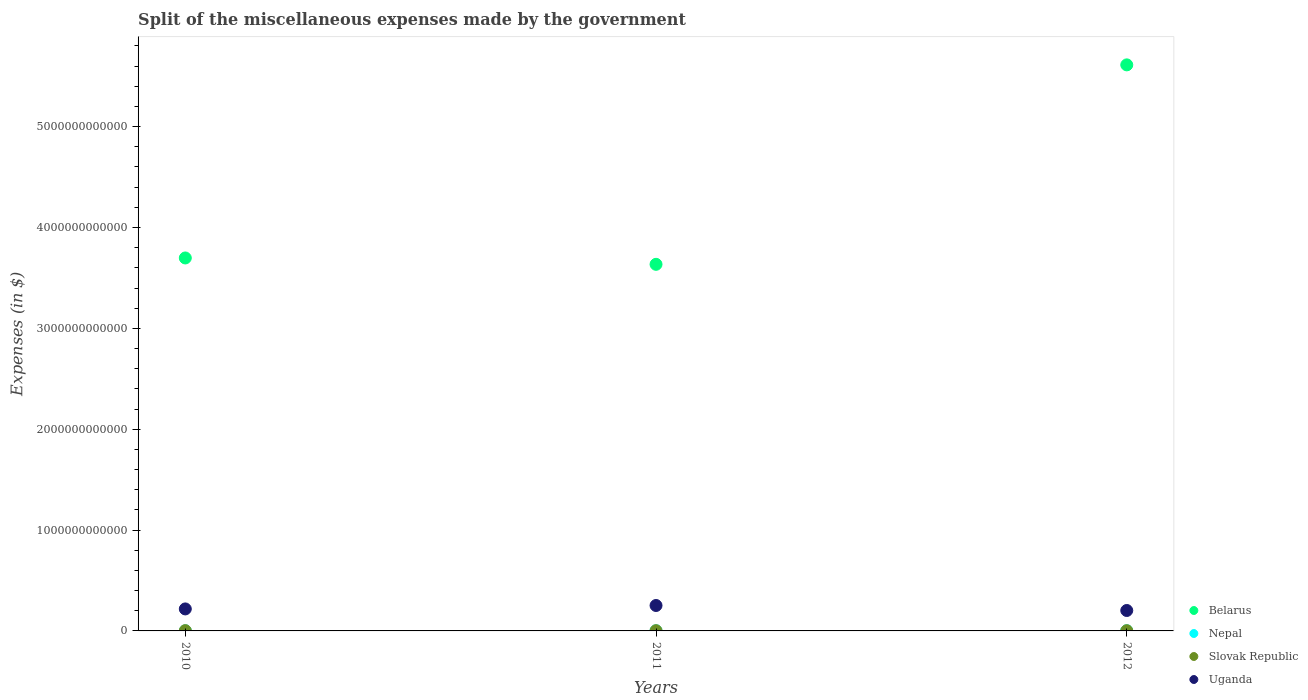Is the number of dotlines equal to the number of legend labels?
Ensure brevity in your answer.  Yes. What is the miscellaneous expenses made by the government in Uganda in 2010?
Give a very brief answer. 2.18e+11. Across all years, what is the maximum miscellaneous expenses made by the government in Slovak Republic?
Give a very brief answer. 2.84e+09. Across all years, what is the minimum miscellaneous expenses made by the government in Slovak Republic?
Offer a very short reply. 2.34e+09. In which year was the miscellaneous expenses made by the government in Uganda maximum?
Offer a very short reply. 2011. In which year was the miscellaneous expenses made by the government in Belarus minimum?
Ensure brevity in your answer.  2011. What is the total miscellaneous expenses made by the government in Slovak Republic in the graph?
Give a very brief answer. 7.58e+09. What is the difference between the miscellaneous expenses made by the government in Nepal in 2011 and that in 2012?
Your answer should be very brief. -1.36e+08. What is the difference between the miscellaneous expenses made by the government in Nepal in 2010 and the miscellaneous expenses made by the government in Belarus in 2012?
Your answer should be compact. -5.61e+12. What is the average miscellaneous expenses made by the government in Nepal per year?
Offer a terse response. 1.75e+09. In the year 2012, what is the difference between the miscellaneous expenses made by the government in Uganda and miscellaneous expenses made by the government in Belarus?
Keep it short and to the point. -5.41e+12. In how many years, is the miscellaneous expenses made by the government in Slovak Republic greater than 3800000000000 $?
Give a very brief answer. 0. What is the ratio of the miscellaneous expenses made by the government in Belarus in 2010 to that in 2011?
Provide a succinct answer. 1.02. What is the difference between the highest and the second highest miscellaneous expenses made by the government in Belarus?
Make the answer very short. 1.91e+12. What is the difference between the highest and the lowest miscellaneous expenses made by the government in Slovak Republic?
Provide a succinct answer. 5.01e+08. Is it the case that in every year, the sum of the miscellaneous expenses made by the government in Slovak Republic and miscellaneous expenses made by the government in Nepal  is greater than the sum of miscellaneous expenses made by the government in Uganda and miscellaneous expenses made by the government in Belarus?
Ensure brevity in your answer.  No. Is it the case that in every year, the sum of the miscellaneous expenses made by the government in Slovak Republic and miscellaneous expenses made by the government in Nepal  is greater than the miscellaneous expenses made by the government in Belarus?
Offer a very short reply. No. Does the miscellaneous expenses made by the government in Slovak Republic monotonically increase over the years?
Provide a short and direct response. No. How many dotlines are there?
Ensure brevity in your answer.  4. How many years are there in the graph?
Your response must be concise. 3. What is the difference between two consecutive major ticks on the Y-axis?
Your answer should be very brief. 1.00e+12. How are the legend labels stacked?
Give a very brief answer. Vertical. What is the title of the graph?
Provide a short and direct response. Split of the miscellaneous expenses made by the government. What is the label or title of the Y-axis?
Your answer should be very brief. Expenses (in $). What is the Expenses (in $) in Belarus in 2010?
Offer a terse response. 3.70e+12. What is the Expenses (in $) in Nepal in 2010?
Provide a short and direct response. 1.38e+09. What is the Expenses (in $) in Slovak Republic in 2010?
Your answer should be very brief. 2.84e+09. What is the Expenses (in $) of Uganda in 2010?
Provide a short and direct response. 2.18e+11. What is the Expenses (in $) in Belarus in 2011?
Offer a very short reply. 3.63e+12. What is the Expenses (in $) of Nepal in 2011?
Provide a succinct answer. 1.86e+09. What is the Expenses (in $) of Slovak Republic in 2011?
Provide a short and direct response. 2.40e+09. What is the Expenses (in $) of Uganda in 2011?
Offer a terse response. 2.52e+11. What is the Expenses (in $) of Belarus in 2012?
Your answer should be very brief. 5.61e+12. What is the Expenses (in $) in Nepal in 2012?
Your answer should be compact. 2.00e+09. What is the Expenses (in $) in Slovak Republic in 2012?
Ensure brevity in your answer.  2.34e+09. What is the Expenses (in $) in Uganda in 2012?
Provide a succinct answer. 2.03e+11. Across all years, what is the maximum Expenses (in $) in Belarus?
Provide a succinct answer. 5.61e+12. Across all years, what is the maximum Expenses (in $) of Nepal?
Keep it short and to the point. 2.00e+09. Across all years, what is the maximum Expenses (in $) of Slovak Republic?
Make the answer very short. 2.84e+09. Across all years, what is the maximum Expenses (in $) in Uganda?
Your response must be concise. 2.52e+11. Across all years, what is the minimum Expenses (in $) in Belarus?
Offer a very short reply. 3.63e+12. Across all years, what is the minimum Expenses (in $) of Nepal?
Offer a very short reply. 1.38e+09. Across all years, what is the minimum Expenses (in $) in Slovak Republic?
Provide a short and direct response. 2.34e+09. Across all years, what is the minimum Expenses (in $) of Uganda?
Your answer should be compact. 2.03e+11. What is the total Expenses (in $) in Belarus in the graph?
Offer a very short reply. 1.29e+13. What is the total Expenses (in $) of Nepal in the graph?
Make the answer very short. 5.24e+09. What is the total Expenses (in $) in Slovak Republic in the graph?
Offer a terse response. 7.58e+09. What is the total Expenses (in $) of Uganda in the graph?
Make the answer very short. 6.73e+11. What is the difference between the Expenses (in $) of Belarus in 2010 and that in 2011?
Give a very brief answer. 6.31e+1. What is the difference between the Expenses (in $) of Nepal in 2010 and that in 2011?
Your response must be concise. -4.77e+08. What is the difference between the Expenses (in $) in Slovak Republic in 2010 and that in 2011?
Keep it short and to the point. 4.40e+08. What is the difference between the Expenses (in $) in Uganda in 2010 and that in 2011?
Your answer should be compact. -3.40e+1. What is the difference between the Expenses (in $) of Belarus in 2010 and that in 2012?
Ensure brevity in your answer.  -1.91e+12. What is the difference between the Expenses (in $) in Nepal in 2010 and that in 2012?
Offer a very short reply. -6.13e+08. What is the difference between the Expenses (in $) in Slovak Republic in 2010 and that in 2012?
Make the answer very short. 5.01e+08. What is the difference between the Expenses (in $) in Uganda in 2010 and that in 2012?
Make the answer very short. 1.55e+1. What is the difference between the Expenses (in $) of Belarus in 2011 and that in 2012?
Ensure brevity in your answer.  -1.98e+12. What is the difference between the Expenses (in $) of Nepal in 2011 and that in 2012?
Give a very brief answer. -1.36e+08. What is the difference between the Expenses (in $) in Slovak Republic in 2011 and that in 2012?
Give a very brief answer. 6.13e+07. What is the difference between the Expenses (in $) in Uganda in 2011 and that in 2012?
Offer a very short reply. 4.95e+1. What is the difference between the Expenses (in $) in Belarus in 2010 and the Expenses (in $) in Nepal in 2011?
Keep it short and to the point. 3.70e+12. What is the difference between the Expenses (in $) of Belarus in 2010 and the Expenses (in $) of Slovak Republic in 2011?
Give a very brief answer. 3.70e+12. What is the difference between the Expenses (in $) of Belarus in 2010 and the Expenses (in $) of Uganda in 2011?
Give a very brief answer. 3.45e+12. What is the difference between the Expenses (in $) of Nepal in 2010 and the Expenses (in $) of Slovak Republic in 2011?
Offer a very short reply. -1.02e+09. What is the difference between the Expenses (in $) in Nepal in 2010 and the Expenses (in $) in Uganda in 2011?
Provide a short and direct response. -2.51e+11. What is the difference between the Expenses (in $) in Slovak Republic in 2010 and the Expenses (in $) in Uganda in 2011?
Provide a short and direct response. -2.49e+11. What is the difference between the Expenses (in $) in Belarus in 2010 and the Expenses (in $) in Nepal in 2012?
Ensure brevity in your answer.  3.70e+12. What is the difference between the Expenses (in $) of Belarus in 2010 and the Expenses (in $) of Slovak Republic in 2012?
Ensure brevity in your answer.  3.70e+12. What is the difference between the Expenses (in $) of Belarus in 2010 and the Expenses (in $) of Uganda in 2012?
Ensure brevity in your answer.  3.50e+12. What is the difference between the Expenses (in $) of Nepal in 2010 and the Expenses (in $) of Slovak Republic in 2012?
Your answer should be very brief. -9.55e+08. What is the difference between the Expenses (in $) in Nepal in 2010 and the Expenses (in $) in Uganda in 2012?
Your answer should be compact. -2.01e+11. What is the difference between the Expenses (in $) of Slovak Republic in 2010 and the Expenses (in $) of Uganda in 2012?
Your answer should be compact. -2.00e+11. What is the difference between the Expenses (in $) in Belarus in 2011 and the Expenses (in $) in Nepal in 2012?
Make the answer very short. 3.63e+12. What is the difference between the Expenses (in $) in Belarus in 2011 and the Expenses (in $) in Slovak Republic in 2012?
Offer a very short reply. 3.63e+12. What is the difference between the Expenses (in $) of Belarus in 2011 and the Expenses (in $) of Uganda in 2012?
Ensure brevity in your answer.  3.43e+12. What is the difference between the Expenses (in $) in Nepal in 2011 and the Expenses (in $) in Slovak Republic in 2012?
Your answer should be compact. -4.78e+08. What is the difference between the Expenses (in $) of Nepal in 2011 and the Expenses (in $) of Uganda in 2012?
Make the answer very short. -2.01e+11. What is the difference between the Expenses (in $) in Slovak Republic in 2011 and the Expenses (in $) in Uganda in 2012?
Keep it short and to the point. -2.00e+11. What is the average Expenses (in $) of Belarus per year?
Provide a succinct answer. 4.32e+12. What is the average Expenses (in $) in Nepal per year?
Your response must be concise. 1.75e+09. What is the average Expenses (in $) of Slovak Republic per year?
Keep it short and to the point. 2.53e+09. What is the average Expenses (in $) in Uganda per year?
Keep it short and to the point. 2.24e+11. In the year 2010, what is the difference between the Expenses (in $) in Belarus and Expenses (in $) in Nepal?
Offer a terse response. 3.70e+12. In the year 2010, what is the difference between the Expenses (in $) of Belarus and Expenses (in $) of Slovak Republic?
Give a very brief answer. 3.70e+12. In the year 2010, what is the difference between the Expenses (in $) in Belarus and Expenses (in $) in Uganda?
Your answer should be very brief. 3.48e+12. In the year 2010, what is the difference between the Expenses (in $) of Nepal and Expenses (in $) of Slovak Republic?
Ensure brevity in your answer.  -1.46e+09. In the year 2010, what is the difference between the Expenses (in $) in Nepal and Expenses (in $) in Uganda?
Your answer should be very brief. -2.17e+11. In the year 2010, what is the difference between the Expenses (in $) in Slovak Republic and Expenses (in $) in Uganda?
Provide a short and direct response. -2.15e+11. In the year 2011, what is the difference between the Expenses (in $) of Belarus and Expenses (in $) of Nepal?
Make the answer very short. 3.63e+12. In the year 2011, what is the difference between the Expenses (in $) in Belarus and Expenses (in $) in Slovak Republic?
Your answer should be very brief. 3.63e+12. In the year 2011, what is the difference between the Expenses (in $) of Belarus and Expenses (in $) of Uganda?
Give a very brief answer. 3.38e+12. In the year 2011, what is the difference between the Expenses (in $) of Nepal and Expenses (in $) of Slovak Republic?
Keep it short and to the point. -5.39e+08. In the year 2011, what is the difference between the Expenses (in $) in Nepal and Expenses (in $) in Uganda?
Your response must be concise. -2.50e+11. In the year 2011, what is the difference between the Expenses (in $) in Slovak Republic and Expenses (in $) in Uganda?
Keep it short and to the point. -2.50e+11. In the year 2012, what is the difference between the Expenses (in $) in Belarus and Expenses (in $) in Nepal?
Give a very brief answer. 5.61e+12. In the year 2012, what is the difference between the Expenses (in $) of Belarus and Expenses (in $) of Slovak Republic?
Keep it short and to the point. 5.61e+12. In the year 2012, what is the difference between the Expenses (in $) of Belarus and Expenses (in $) of Uganda?
Give a very brief answer. 5.41e+12. In the year 2012, what is the difference between the Expenses (in $) of Nepal and Expenses (in $) of Slovak Republic?
Give a very brief answer. -3.43e+08. In the year 2012, what is the difference between the Expenses (in $) of Nepal and Expenses (in $) of Uganda?
Make the answer very short. -2.01e+11. In the year 2012, what is the difference between the Expenses (in $) of Slovak Republic and Expenses (in $) of Uganda?
Your response must be concise. -2.00e+11. What is the ratio of the Expenses (in $) in Belarus in 2010 to that in 2011?
Keep it short and to the point. 1.02. What is the ratio of the Expenses (in $) in Nepal in 2010 to that in 2011?
Provide a short and direct response. 0.74. What is the ratio of the Expenses (in $) of Slovak Republic in 2010 to that in 2011?
Ensure brevity in your answer.  1.18. What is the ratio of the Expenses (in $) in Uganda in 2010 to that in 2011?
Your answer should be very brief. 0.87. What is the ratio of the Expenses (in $) in Belarus in 2010 to that in 2012?
Keep it short and to the point. 0.66. What is the ratio of the Expenses (in $) in Nepal in 2010 to that in 2012?
Keep it short and to the point. 0.69. What is the ratio of the Expenses (in $) in Slovak Republic in 2010 to that in 2012?
Offer a terse response. 1.21. What is the ratio of the Expenses (in $) of Uganda in 2010 to that in 2012?
Ensure brevity in your answer.  1.08. What is the ratio of the Expenses (in $) of Belarus in 2011 to that in 2012?
Ensure brevity in your answer.  0.65. What is the ratio of the Expenses (in $) of Nepal in 2011 to that in 2012?
Ensure brevity in your answer.  0.93. What is the ratio of the Expenses (in $) in Slovak Republic in 2011 to that in 2012?
Offer a very short reply. 1.03. What is the ratio of the Expenses (in $) in Uganda in 2011 to that in 2012?
Keep it short and to the point. 1.24. What is the difference between the highest and the second highest Expenses (in $) in Belarus?
Give a very brief answer. 1.91e+12. What is the difference between the highest and the second highest Expenses (in $) of Nepal?
Offer a terse response. 1.36e+08. What is the difference between the highest and the second highest Expenses (in $) of Slovak Republic?
Give a very brief answer. 4.40e+08. What is the difference between the highest and the second highest Expenses (in $) in Uganda?
Your answer should be very brief. 3.40e+1. What is the difference between the highest and the lowest Expenses (in $) in Belarus?
Make the answer very short. 1.98e+12. What is the difference between the highest and the lowest Expenses (in $) of Nepal?
Provide a short and direct response. 6.13e+08. What is the difference between the highest and the lowest Expenses (in $) of Slovak Republic?
Make the answer very short. 5.01e+08. What is the difference between the highest and the lowest Expenses (in $) in Uganda?
Offer a terse response. 4.95e+1. 